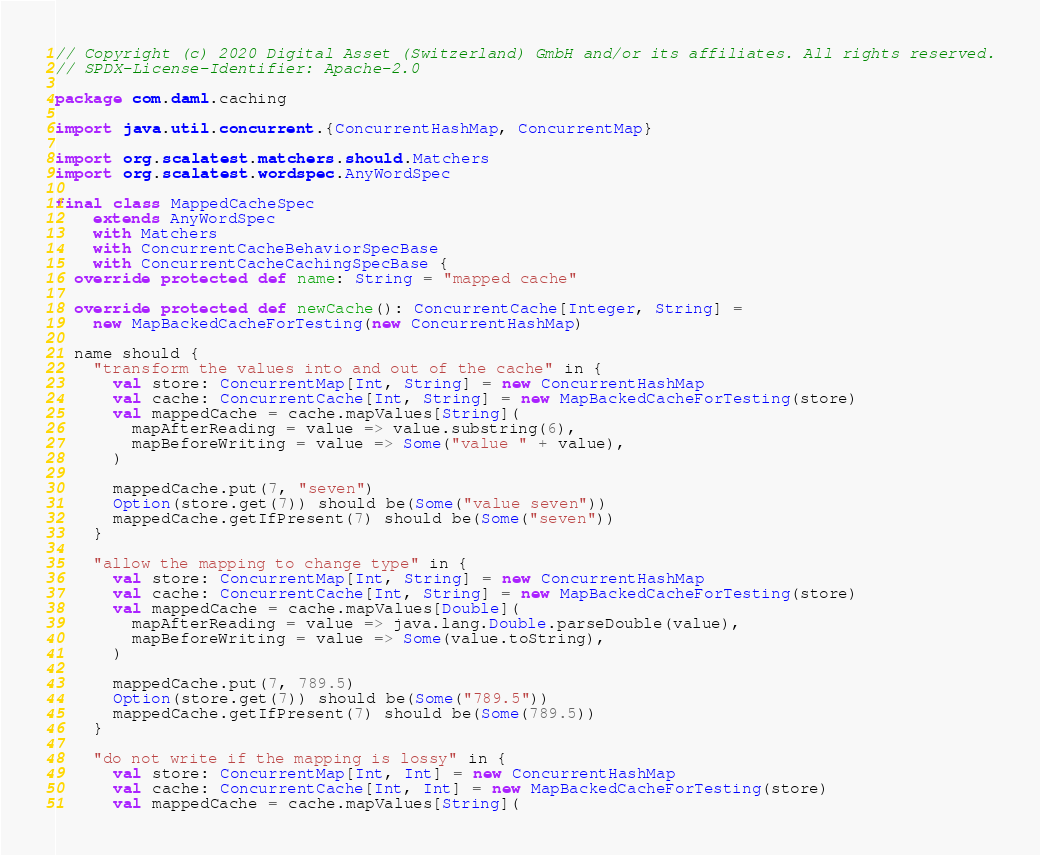<code> <loc_0><loc_0><loc_500><loc_500><_Scala_>// Copyright (c) 2020 Digital Asset (Switzerland) GmbH and/or its affiliates. All rights reserved.
// SPDX-License-Identifier: Apache-2.0

package com.daml.caching

import java.util.concurrent.{ConcurrentHashMap, ConcurrentMap}

import org.scalatest.matchers.should.Matchers
import org.scalatest.wordspec.AnyWordSpec

final class MappedCacheSpec
    extends AnyWordSpec
    with Matchers
    with ConcurrentCacheBehaviorSpecBase
    with ConcurrentCacheCachingSpecBase {
  override protected def name: String = "mapped cache"

  override protected def newCache(): ConcurrentCache[Integer, String] =
    new MapBackedCacheForTesting(new ConcurrentHashMap)

  name should {
    "transform the values into and out of the cache" in {
      val store: ConcurrentMap[Int, String] = new ConcurrentHashMap
      val cache: ConcurrentCache[Int, String] = new MapBackedCacheForTesting(store)
      val mappedCache = cache.mapValues[String](
        mapAfterReading = value => value.substring(6),
        mapBeforeWriting = value => Some("value " + value),
      )

      mappedCache.put(7, "seven")
      Option(store.get(7)) should be(Some("value seven"))
      mappedCache.getIfPresent(7) should be(Some("seven"))
    }

    "allow the mapping to change type" in {
      val store: ConcurrentMap[Int, String] = new ConcurrentHashMap
      val cache: ConcurrentCache[Int, String] = new MapBackedCacheForTesting(store)
      val mappedCache = cache.mapValues[Double](
        mapAfterReading = value => java.lang.Double.parseDouble(value),
        mapBeforeWriting = value => Some(value.toString),
      )

      mappedCache.put(7, 789.5)
      Option(store.get(7)) should be(Some("789.5"))
      mappedCache.getIfPresent(7) should be(Some(789.5))
    }

    "do not write if the mapping is lossy" in {
      val store: ConcurrentMap[Int, Int] = new ConcurrentHashMap
      val cache: ConcurrentCache[Int, Int] = new MapBackedCacheForTesting(store)
      val mappedCache = cache.mapValues[String](</code> 